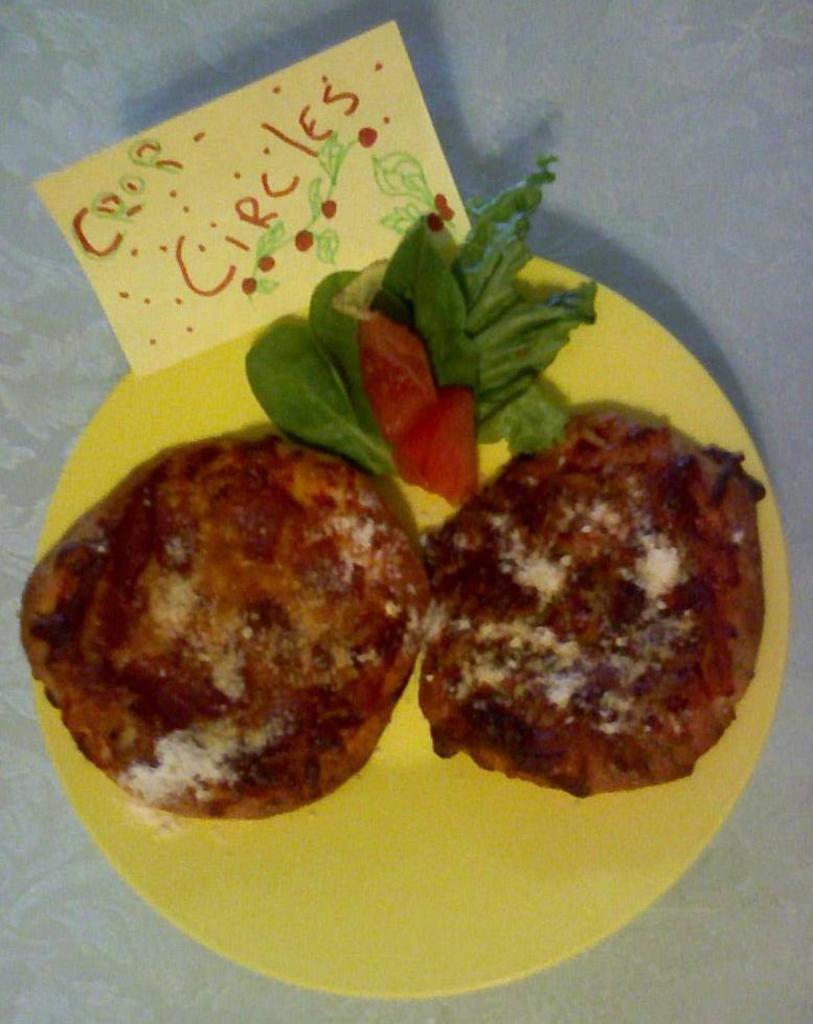How would you summarize this image in a sentence or two? In this image I can see a food item in the plate. There is some text. 